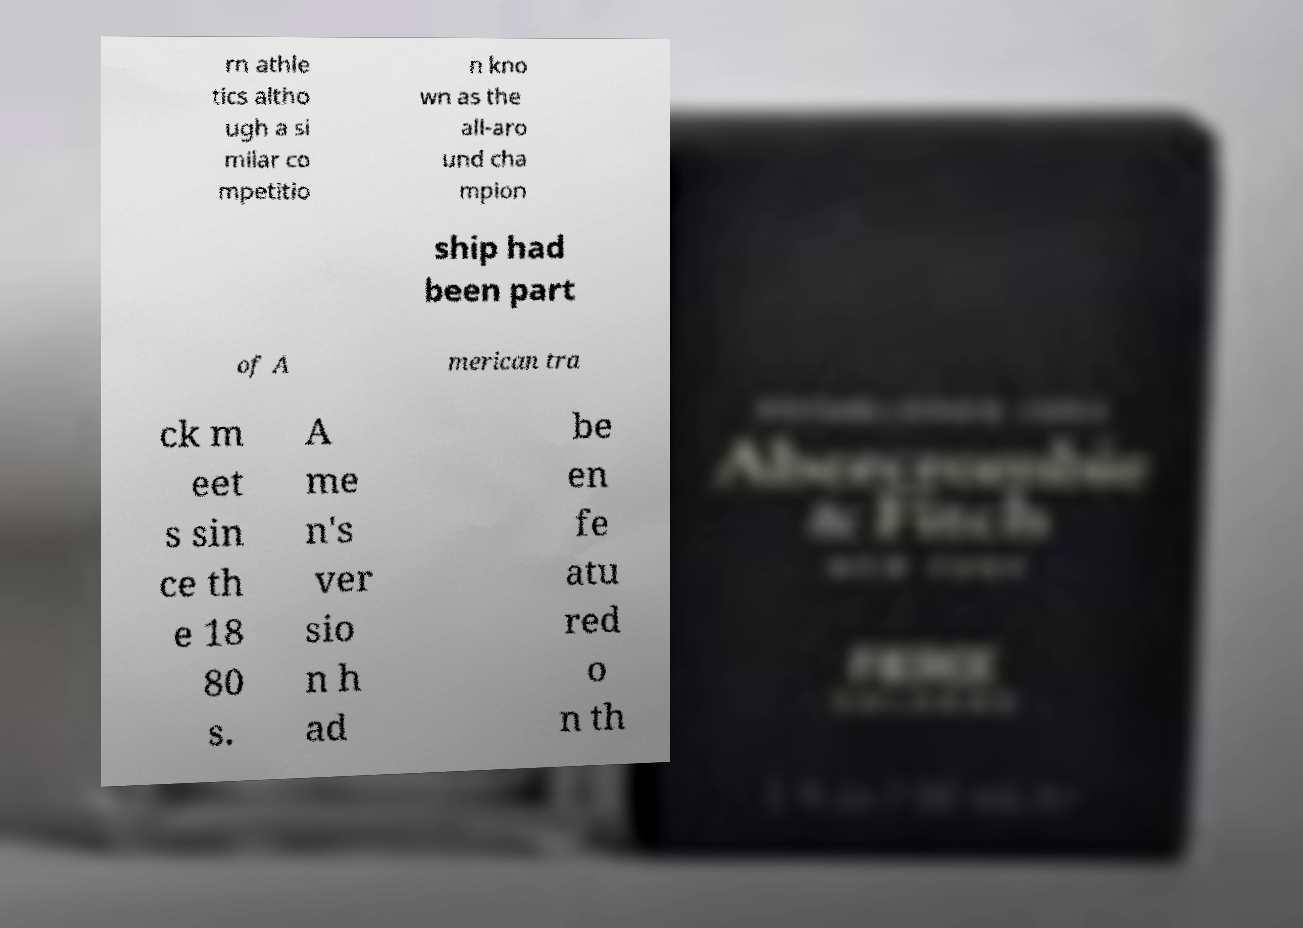What messages or text are displayed in this image? I need them in a readable, typed format. rn athle tics altho ugh a si milar co mpetitio n kno wn as the all-aro und cha mpion ship had been part of A merican tra ck m eet s sin ce th e 18 80 s. A me n's ver sio n h ad be en fe atu red o n th 